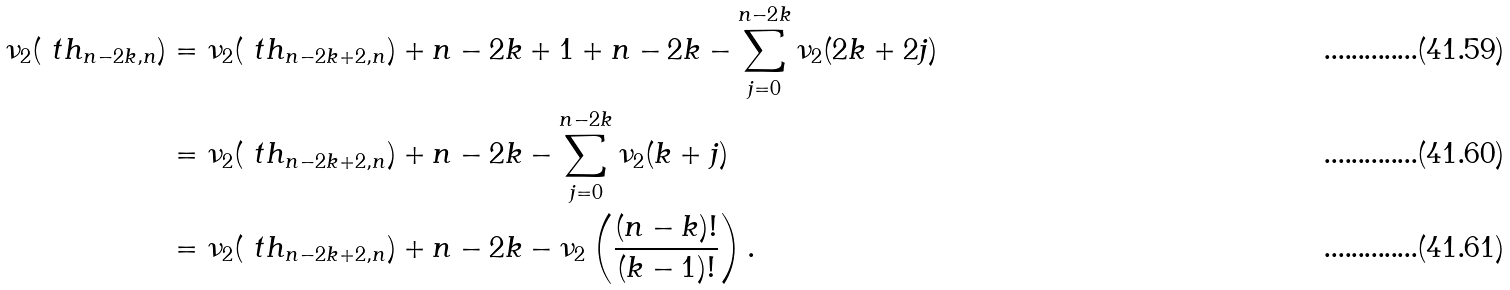<formula> <loc_0><loc_0><loc_500><loc_500>\nu _ { 2 } ( \ t h _ { n - 2 k , n } ) & = \nu _ { 2 } ( \ t h _ { n - 2 k + 2 , n } ) + n - 2 k + 1 + n - 2 k - \sum _ { j = 0 } ^ { n - 2 k } \nu _ { 2 } ( 2 k + 2 j ) \\ & = \nu _ { 2 } ( \ t h _ { n - 2 k + 2 , n } ) + n - 2 k - \sum _ { j = 0 } ^ { n - 2 k } \nu _ { 2 } ( k + j ) \\ & = \nu _ { 2 } ( \ t h _ { n - 2 k + 2 , n } ) + n - 2 k - \nu _ { 2 } \left ( \frac { ( n - k ) ! } { ( k - 1 ) ! } \right ) .</formula> 